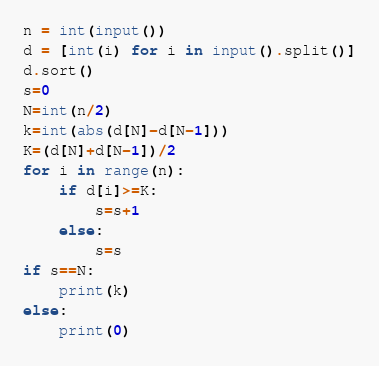<code> <loc_0><loc_0><loc_500><loc_500><_Python_>n = int(input())
d = [int(i) for i in input().split()]
d.sort()
s=0
N=int(n/2)
k=int(abs(d[N]-d[N-1]))
K=(d[N]+d[N-1])/2
for i in range(n):
    if d[i]>=K:
        s=s+1
    else:
        s=s
if s==N:
    print(k)
else:
    print(0)</code> 